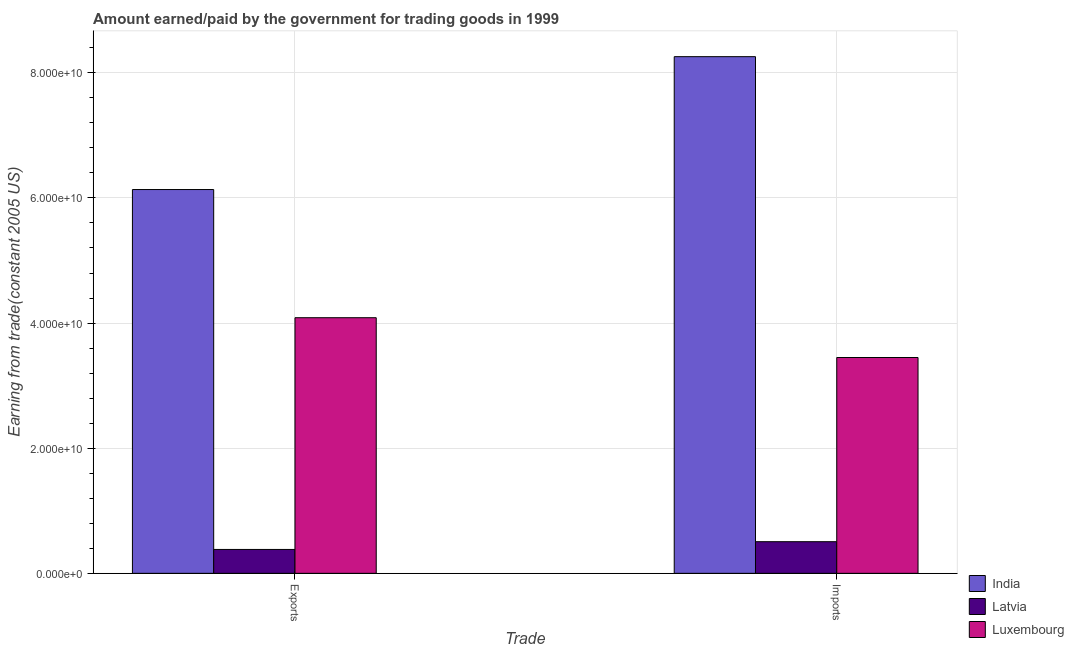How many different coloured bars are there?
Keep it short and to the point. 3. How many groups of bars are there?
Offer a terse response. 2. Are the number of bars per tick equal to the number of legend labels?
Keep it short and to the point. Yes. How many bars are there on the 1st tick from the left?
Make the answer very short. 3. How many bars are there on the 2nd tick from the right?
Make the answer very short. 3. What is the label of the 2nd group of bars from the left?
Your answer should be compact. Imports. What is the amount paid for imports in Latvia?
Give a very brief answer. 5.06e+09. Across all countries, what is the maximum amount earned from exports?
Give a very brief answer. 6.13e+1. Across all countries, what is the minimum amount paid for imports?
Your response must be concise. 5.06e+09. In which country was the amount earned from exports maximum?
Provide a succinct answer. India. In which country was the amount paid for imports minimum?
Offer a very short reply. Latvia. What is the total amount earned from exports in the graph?
Keep it short and to the point. 1.06e+11. What is the difference between the amount paid for imports in India and that in Latvia?
Make the answer very short. 7.75e+1. What is the difference between the amount earned from exports in Luxembourg and the amount paid for imports in India?
Provide a short and direct response. -4.17e+1. What is the average amount paid for imports per country?
Provide a succinct answer. 4.07e+1. What is the difference between the amount paid for imports and amount earned from exports in Latvia?
Your response must be concise. 1.24e+09. In how many countries, is the amount earned from exports greater than 24000000000 US$?
Your answer should be very brief. 2. What is the ratio of the amount earned from exports in Luxembourg to that in Latvia?
Provide a short and direct response. 10.7. Is the amount paid for imports in Latvia less than that in Luxembourg?
Your answer should be very brief. Yes. What does the 3rd bar from the left in Imports represents?
Offer a terse response. Luxembourg. What does the 1st bar from the right in Exports represents?
Provide a succinct answer. Luxembourg. What is the difference between two consecutive major ticks on the Y-axis?
Make the answer very short. 2.00e+1. Are the values on the major ticks of Y-axis written in scientific E-notation?
Your answer should be very brief. Yes. Does the graph contain any zero values?
Your answer should be compact. No. Does the graph contain grids?
Offer a very short reply. Yes. How many legend labels are there?
Provide a short and direct response. 3. How are the legend labels stacked?
Keep it short and to the point. Vertical. What is the title of the graph?
Provide a short and direct response. Amount earned/paid by the government for trading goods in 1999. What is the label or title of the X-axis?
Your response must be concise. Trade. What is the label or title of the Y-axis?
Provide a short and direct response. Earning from trade(constant 2005 US). What is the Earning from trade(constant 2005 US) of India in Exports?
Offer a very short reply. 6.13e+1. What is the Earning from trade(constant 2005 US) of Latvia in Exports?
Provide a short and direct response. 3.82e+09. What is the Earning from trade(constant 2005 US) in Luxembourg in Exports?
Make the answer very short. 4.09e+1. What is the Earning from trade(constant 2005 US) of India in Imports?
Keep it short and to the point. 8.26e+1. What is the Earning from trade(constant 2005 US) of Latvia in Imports?
Your answer should be very brief. 5.06e+09. What is the Earning from trade(constant 2005 US) of Luxembourg in Imports?
Ensure brevity in your answer.  3.45e+1. Across all Trade, what is the maximum Earning from trade(constant 2005 US) of India?
Your response must be concise. 8.26e+1. Across all Trade, what is the maximum Earning from trade(constant 2005 US) in Latvia?
Offer a terse response. 5.06e+09. Across all Trade, what is the maximum Earning from trade(constant 2005 US) in Luxembourg?
Keep it short and to the point. 4.09e+1. Across all Trade, what is the minimum Earning from trade(constant 2005 US) of India?
Provide a short and direct response. 6.13e+1. Across all Trade, what is the minimum Earning from trade(constant 2005 US) of Latvia?
Your answer should be compact. 3.82e+09. Across all Trade, what is the minimum Earning from trade(constant 2005 US) in Luxembourg?
Offer a very short reply. 3.45e+1. What is the total Earning from trade(constant 2005 US) of India in the graph?
Your answer should be very brief. 1.44e+11. What is the total Earning from trade(constant 2005 US) in Latvia in the graph?
Your response must be concise. 8.87e+09. What is the total Earning from trade(constant 2005 US) in Luxembourg in the graph?
Offer a terse response. 7.54e+1. What is the difference between the Earning from trade(constant 2005 US) of India in Exports and that in Imports?
Offer a terse response. -2.12e+1. What is the difference between the Earning from trade(constant 2005 US) of Latvia in Exports and that in Imports?
Make the answer very short. -1.24e+09. What is the difference between the Earning from trade(constant 2005 US) in Luxembourg in Exports and that in Imports?
Give a very brief answer. 6.36e+09. What is the difference between the Earning from trade(constant 2005 US) in India in Exports and the Earning from trade(constant 2005 US) in Latvia in Imports?
Provide a short and direct response. 5.63e+1. What is the difference between the Earning from trade(constant 2005 US) of India in Exports and the Earning from trade(constant 2005 US) of Luxembourg in Imports?
Your response must be concise. 2.68e+1. What is the difference between the Earning from trade(constant 2005 US) in Latvia in Exports and the Earning from trade(constant 2005 US) in Luxembourg in Imports?
Offer a very short reply. -3.07e+1. What is the average Earning from trade(constant 2005 US) of India per Trade?
Give a very brief answer. 7.20e+1. What is the average Earning from trade(constant 2005 US) of Latvia per Trade?
Provide a short and direct response. 4.44e+09. What is the average Earning from trade(constant 2005 US) of Luxembourg per Trade?
Offer a very short reply. 3.77e+1. What is the difference between the Earning from trade(constant 2005 US) of India and Earning from trade(constant 2005 US) of Latvia in Exports?
Your answer should be compact. 5.75e+1. What is the difference between the Earning from trade(constant 2005 US) of India and Earning from trade(constant 2005 US) of Luxembourg in Exports?
Ensure brevity in your answer.  2.05e+1. What is the difference between the Earning from trade(constant 2005 US) of Latvia and Earning from trade(constant 2005 US) of Luxembourg in Exports?
Your answer should be very brief. -3.70e+1. What is the difference between the Earning from trade(constant 2005 US) in India and Earning from trade(constant 2005 US) in Latvia in Imports?
Your answer should be compact. 7.75e+1. What is the difference between the Earning from trade(constant 2005 US) in India and Earning from trade(constant 2005 US) in Luxembourg in Imports?
Provide a succinct answer. 4.81e+1. What is the difference between the Earning from trade(constant 2005 US) of Latvia and Earning from trade(constant 2005 US) of Luxembourg in Imports?
Ensure brevity in your answer.  -2.94e+1. What is the ratio of the Earning from trade(constant 2005 US) of India in Exports to that in Imports?
Your answer should be compact. 0.74. What is the ratio of the Earning from trade(constant 2005 US) in Latvia in Exports to that in Imports?
Give a very brief answer. 0.75. What is the ratio of the Earning from trade(constant 2005 US) of Luxembourg in Exports to that in Imports?
Offer a very short reply. 1.18. What is the difference between the highest and the second highest Earning from trade(constant 2005 US) of India?
Your response must be concise. 2.12e+1. What is the difference between the highest and the second highest Earning from trade(constant 2005 US) of Latvia?
Your answer should be very brief. 1.24e+09. What is the difference between the highest and the second highest Earning from trade(constant 2005 US) in Luxembourg?
Make the answer very short. 6.36e+09. What is the difference between the highest and the lowest Earning from trade(constant 2005 US) of India?
Provide a short and direct response. 2.12e+1. What is the difference between the highest and the lowest Earning from trade(constant 2005 US) in Latvia?
Keep it short and to the point. 1.24e+09. What is the difference between the highest and the lowest Earning from trade(constant 2005 US) in Luxembourg?
Keep it short and to the point. 6.36e+09. 